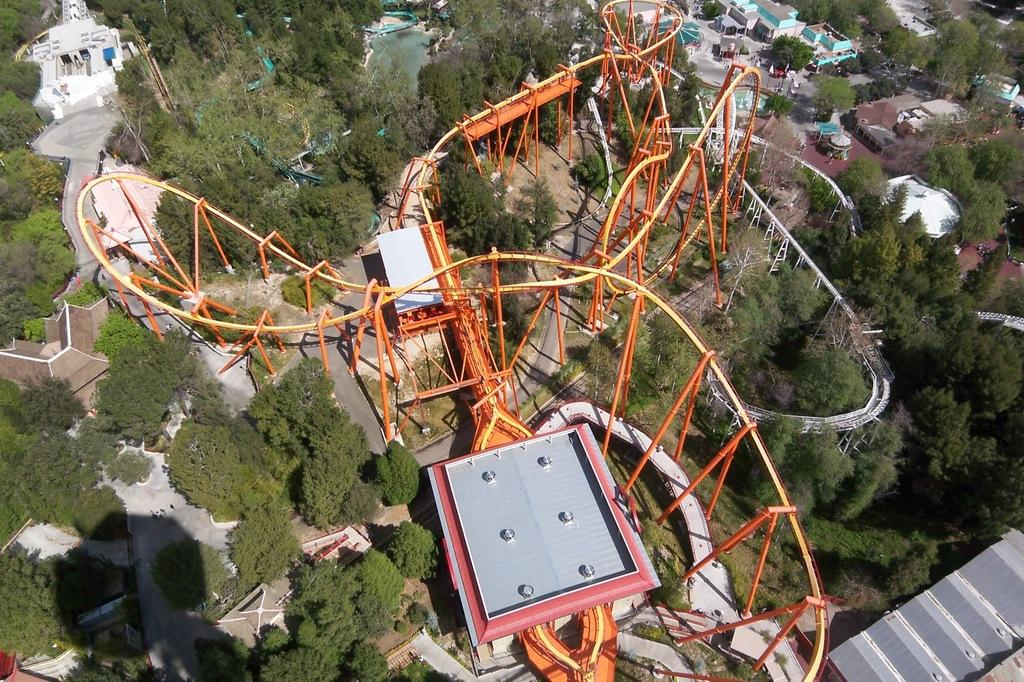What is the main subject of the image? The main subject of the image is a roller coaster. Can you describe the roller coaster in the image? The roller coaster is orange in color. What can be seen on the right side of the image? There are trees and buildings on the right side of the image. What type of dress is the bat wearing in the image? There is no bat or dress present in the image. 